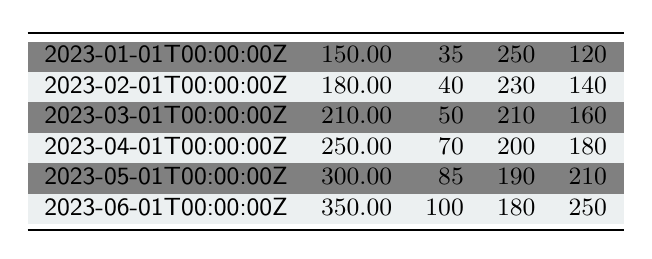What is the total amount of data transferred in January and February 2023? The data transferred in January is 150 MB and in February is 180 MB. Adding these values gives 150 + 180 = 330 MB.
Answer: 330 MB What was the average response time in March 2023? The average response time in March 2023 is provided directly in the table, which is 210 ms.
Answer: 210 ms Did the number of active sessions increase from April to June 2023? In April 2023, there were 70 active sessions, and in June 2023, there were 100 active sessions. Since 100 > 70, this indicates an increase.
Answer: Yes What is the peak user count difference between April and May 2023? The peak user count in April 2023 is 180, and in May 2023 it is 210. The difference is calculated as 210 - 180 = 30.
Answer: 30 What is the average data transferred over the six months? The total data transferred over six months is calculated as 150 + 180 + 210 + 250 + 300 + 350 = 1440 MB. Since there are 6 months, the average is 1440 / 6 = 240 MB.
Answer: 240 MB Was the average response time in April better than that in February 2023? The average response time in April was 200 ms, and in February it was 230 ms. Since 200 < 230, it indicates that the average response time in April is better (lower).
Answer: Yes What was the percentage increase in peak users from January to June 2023? The peak users in January was 120 and in June it was 250. The increase is calculated as ((250 - 120) / 120) * 100 = 108.33%.
Answer: 108.33% Which month had the highest data transfer and what was the value? Referring to the data, June 2023 had the highest data transferred at 350 MB.
Answer: June 2023, 350 MB What is the trend in average response time from January to June 2023? The average response times are 250 ms in January, 230 ms in February, 210 ms in March, 200 ms in April, 190 ms in May, and 180 ms in June. The values are consistently decreasing, indicating an improvement in response times.
Answer: Decreasing trend 